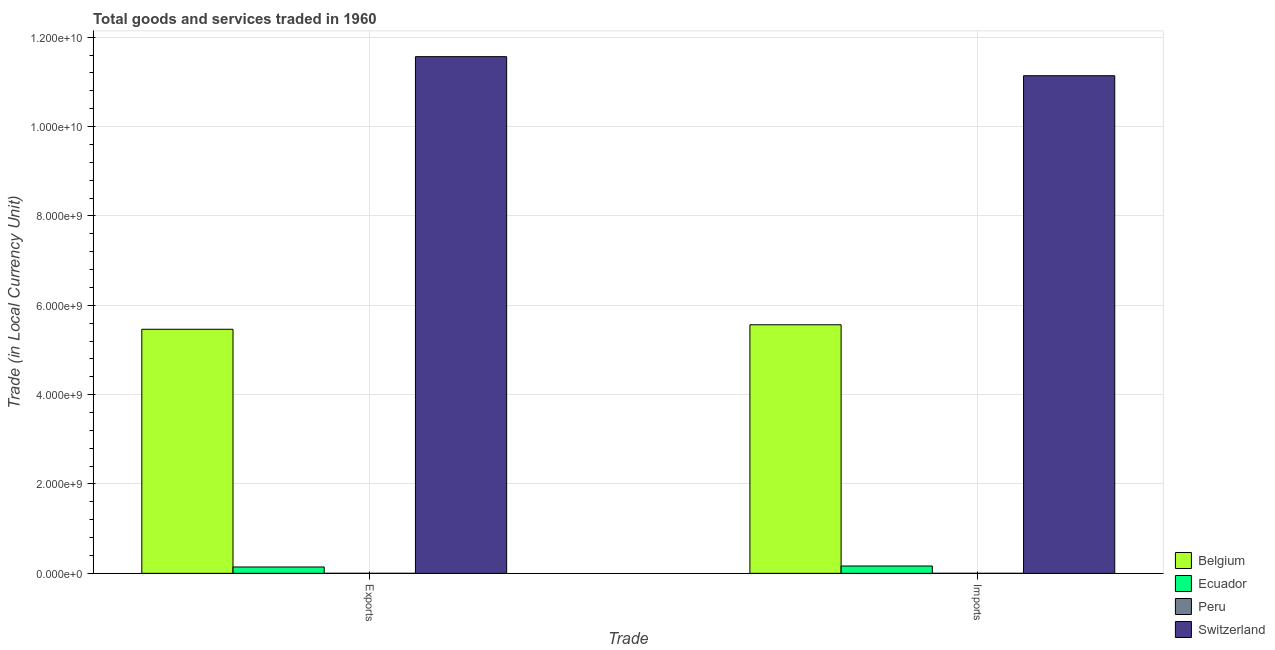Are the number of bars per tick equal to the number of legend labels?
Provide a short and direct response. Yes. Are the number of bars on each tick of the X-axis equal?
Give a very brief answer. Yes. How many bars are there on the 2nd tick from the left?
Your answer should be very brief. 4. What is the label of the 1st group of bars from the left?
Offer a terse response. Exports. What is the export of goods and services in Belgium?
Give a very brief answer. 5.46e+09. Across all countries, what is the maximum export of goods and services?
Give a very brief answer. 1.16e+1. Across all countries, what is the minimum imports of goods and services?
Give a very brief answer. 14.23. In which country was the export of goods and services maximum?
Provide a short and direct response. Switzerland. In which country was the imports of goods and services minimum?
Provide a succinct answer. Peru. What is the total imports of goods and services in the graph?
Provide a short and direct response. 1.69e+1. What is the difference between the export of goods and services in Ecuador and that in Switzerland?
Offer a terse response. -1.14e+1. What is the difference between the imports of goods and services in Switzerland and the export of goods and services in Peru?
Keep it short and to the point. 1.11e+1. What is the average export of goods and services per country?
Keep it short and to the point. 4.29e+09. What is the difference between the imports of goods and services and export of goods and services in Switzerland?
Ensure brevity in your answer.  -4.27e+08. What is the ratio of the export of goods and services in Peru to that in Belgium?
Provide a short and direct response. 2.597913959617587e-9. Is the imports of goods and services in Switzerland less than that in Peru?
Offer a very short reply. No. What does the 1st bar from the left in Imports represents?
Provide a short and direct response. Belgium. How many countries are there in the graph?
Keep it short and to the point. 4. Where does the legend appear in the graph?
Provide a succinct answer. Bottom right. How many legend labels are there?
Ensure brevity in your answer.  4. What is the title of the graph?
Provide a succinct answer. Total goods and services traded in 1960. What is the label or title of the X-axis?
Provide a succinct answer. Trade. What is the label or title of the Y-axis?
Offer a very short reply. Trade (in Local Currency Unit). What is the Trade (in Local Currency Unit) in Belgium in Exports?
Offer a terse response. 5.46e+09. What is the Trade (in Local Currency Unit) in Ecuador in Exports?
Make the answer very short. 1.42e+08. What is the Trade (in Local Currency Unit) in Peru in Exports?
Your answer should be very brief. 14.19. What is the Trade (in Local Currency Unit) of Switzerland in Exports?
Ensure brevity in your answer.  1.16e+1. What is the Trade (in Local Currency Unit) in Belgium in Imports?
Ensure brevity in your answer.  5.56e+09. What is the Trade (in Local Currency Unit) in Ecuador in Imports?
Your answer should be very brief. 1.64e+08. What is the Trade (in Local Currency Unit) of Peru in Imports?
Your answer should be compact. 14.23. What is the Trade (in Local Currency Unit) in Switzerland in Imports?
Your response must be concise. 1.11e+1. Across all Trade, what is the maximum Trade (in Local Currency Unit) of Belgium?
Your answer should be very brief. 5.56e+09. Across all Trade, what is the maximum Trade (in Local Currency Unit) of Ecuador?
Give a very brief answer. 1.64e+08. Across all Trade, what is the maximum Trade (in Local Currency Unit) of Peru?
Make the answer very short. 14.23. Across all Trade, what is the maximum Trade (in Local Currency Unit) in Switzerland?
Offer a terse response. 1.16e+1. Across all Trade, what is the minimum Trade (in Local Currency Unit) of Belgium?
Make the answer very short. 5.46e+09. Across all Trade, what is the minimum Trade (in Local Currency Unit) in Ecuador?
Your answer should be compact. 1.42e+08. Across all Trade, what is the minimum Trade (in Local Currency Unit) in Peru?
Provide a short and direct response. 14.19. Across all Trade, what is the minimum Trade (in Local Currency Unit) in Switzerland?
Offer a very short reply. 1.11e+1. What is the total Trade (in Local Currency Unit) in Belgium in the graph?
Your answer should be very brief. 1.10e+1. What is the total Trade (in Local Currency Unit) in Ecuador in the graph?
Your answer should be compact. 3.06e+08. What is the total Trade (in Local Currency Unit) in Peru in the graph?
Your answer should be very brief. 28.42. What is the total Trade (in Local Currency Unit) of Switzerland in the graph?
Provide a short and direct response. 2.27e+1. What is the difference between the Trade (in Local Currency Unit) in Belgium in Exports and that in Imports?
Ensure brevity in your answer.  -1.01e+08. What is the difference between the Trade (in Local Currency Unit) of Ecuador in Exports and that in Imports?
Offer a very short reply. -2.22e+07. What is the difference between the Trade (in Local Currency Unit) of Peru in Exports and that in Imports?
Offer a terse response. -0.04. What is the difference between the Trade (in Local Currency Unit) of Switzerland in Exports and that in Imports?
Give a very brief answer. 4.27e+08. What is the difference between the Trade (in Local Currency Unit) of Belgium in Exports and the Trade (in Local Currency Unit) of Ecuador in Imports?
Provide a succinct answer. 5.30e+09. What is the difference between the Trade (in Local Currency Unit) in Belgium in Exports and the Trade (in Local Currency Unit) in Peru in Imports?
Offer a very short reply. 5.46e+09. What is the difference between the Trade (in Local Currency Unit) of Belgium in Exports and the Trade (in Local Currency Unit) of Switzerland in Imports?
Ensure brevity in your answer.  -5.67e+09. What is the difference between the Trade (in Local Currency Unit) of Ecuador in Exports and the Trade (in Local Currency Unit) of Peru in Imports?
Give a very brief answer. 1.42e+08. What is the difference between the Trade (in Local Currency Unit) of Ecuador in Exports and the Trade (in Local Currency Unit) of Switzerland in Imports?
Make the answer very short. -1.10e+1. What is the difference between the Trade (in Local Currency Unit) of Peru in Exports and the Trade (in Local Currency Unit) of Switzerland in Imports?
Give a very brief answer. -1.11e+1. What is the average Trade (in Local Currency Unit) in Belgium per Trade?
Your answer should be compact. 5.51e+09. What is the average Trade (in Local Currency Unit) in Ecuador per Trade?
Provide a short and direct response. 1.53e+08. What is the average Trade (in Local Currency Unit) in Peru per Trade?
Your answer should be compact. 14.21. What is the average Trade (in Local Currency Unit) in Switzerland per Trade?
Your answer should be compact. 1.14e+1. What is the difference between the Trade (in Local Currency Unit) of Belgium and Trade (in Local Currency Unit) of Ecuador in Exports?
Provide a succinct answer. 5.32e+09. What is the difference between the Trade (in Local Currency Unit) of Belgium and Trade (in Local Currency Unit) of Peru in Exports?
Offer a very short reply. 5.46e+09. What is the difference between the Trade (in Local Currency Unit) in Belgium and Trade (in Local Currency Unit) in Switzerland in Exports?
Your response must be concise. -6.10e+09. What is the difference between the Trade (in Local Currency Unit) in Ecuador and Trade (in Local Currency Unit) in Peru in Exports?
Provide a short and direct response. 1.42e+08. What is the difference between the Trade (in Local Currency Unit) of Ecuador and Trade (in Local Currency Unit) of Switzerland in Exports?
Your answer should be very brief. -1.14e+1. What is the difference between the Trade (in Local Currency Unit) in Peru and Trade (in Local Currency Unit) in Switzerland in Exports?
Provide a short and direct response. -1.16e+1. What is the difference between the Trade (in Local Currency Unit) of Belgium and Trade (in Local Currency Unit) of Ecuador in Imports?
Make the answer very short. 5.40e+09. What is the difference between the Trade (in Local Currency Unit) in Belgium and Trade (in Local Currency Unit) in Peru in Imports?
Keep it short and to the point. 5.56e+09. What is the difference between the Trade (in Local Currency Unit) of Belgium and Trade (in Local Currency Unit) of Switzerland in Imports?
Give a very brief answer. -5.57e+09. What is the difference between the Trade (in Local Currency Unit) in Ecuador and Trade (in Local Currency Unit) in Peru in Imports?
Give a very brief answer. 1.64e+08. What is the difference between the Trade (in Local Currency Unit) in Ecuador and Trade (in Local Currency Unit) in Switzerland in Imports?
Provide a succinct answer. -1.10e+1. What is the difference between the Trade (in Local Currency Unit) of Peru and Trade (in Local Currency Unit) of Switzerland in Imports?
Make the answer very short. -1.11e+1. What is the ratio of the Trade (in Local Currency Unit) of Belgium in Exports to that in Imports?
Provide a short and direct response. 0.98. What is the ratio of the Trade (in Local Currency Unit) of Ecuador in Exports to that in Imports?
Your response must be concise. 0.86. What is the ratio of the Trade (in Local Currency Unit) of Peru in Exports to that in Imports?
Make the answer very short. 1. What is the ratio of the Trade (in Local Currency Unit) in Switzerland in Exports to that in Imports?
Keep it short and to the point. 1.04. What is the difference between the highest and the second highest Trade (in Local Currency Unit) of Belgium?
Your answer should be very brief. 1.01e+08. What is the difference between the highest and the second highest Trade (in Local Currency Unit) in Ecuador?
Keep it short and to the point. 2.22e+07. What is the difference between the highest and the second highest Trade (in Local Currency Unit) in Peru?
Offer a very short reply. 0.04. What is the difference between the highest and the second highest Trade (in Local Currency Unit) in Switzerland?
Offer a terse response. 4.27e+08. What is the difference between the highest and the lowest Trade (in Local Currency Unit) in Belgium?
Your answer should be very brief. 1.01e+08. What is the difference between the highest and the lowest Trade (in Local Currency Unit) of Ecuador?
Ensure brevity in your answer.  2.22e+07. What is the difference between the highest and the lowest Trade (in Local Currency Unit) of Peru?
Your answer should be very brief. 0.04. What is the difference between the highest and the lowest Trade (in Local Currency Unit) in Switzerland?
Give a very brief answer. 4.27e+08. 